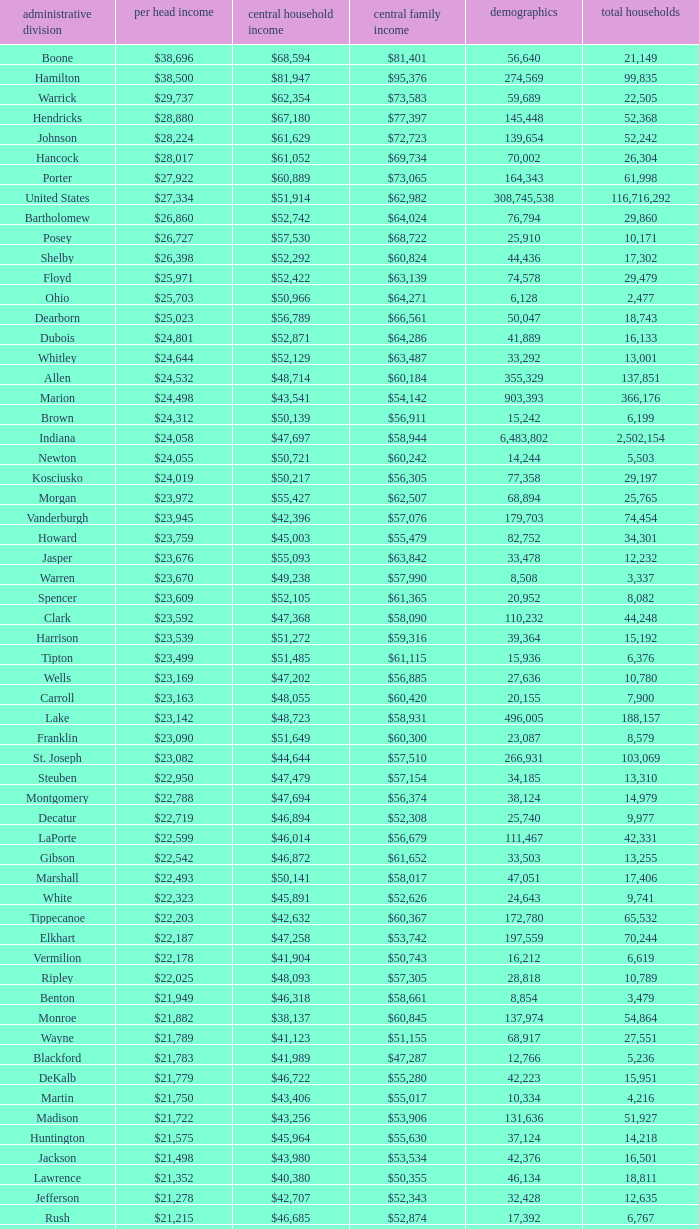What is the Median family income when the Median household income is $38,137? $60,845. Give me the full table as a dictionary. {'header': ['administrative division', 'per head income', 'central household income', 'central family income', 'demographics', 'total households'], 'rows': [['Boone', '$38,696', '$68,594', '$81,401', '56,640', '21,149'], ['Hamilton', '$38,500', '$81,947', '$95,376', '274,569', '99,835'], ['Warrick', '$29,737', '$62,354', '$73,583', '59,689', '22,505'], ['Hendricks', '$28,880', '$67,180', '$77,397', '145,448', '52,368'], ['Johnson', '$28,224', '$61,629', '$72,723', '139,654', '52,242'], ['Hancock', '$28,017', '$61,052', '$69,734', '70,002', '26,304'], ['Porter', '$27,922', '$60,889', '$73,065', '164,343', '61,998'], ['United States', '$27,334', '$51,914', '$62,982', '308,745,538', '116,716,292'], ['Bartholomew', '$26,860', '$52,742', '$64,024', '76,794', '29,860'], ['Posey', '$26,727', '$57,530', '$68,722', '25,910', '10,171'], ['Shelby', '$26,398', '$52,292', '$60,824', '44,436', '17,302'], ['Floyd', '$25,971', '$52,422', '$63,139', '74,578', '29,479'], ['Ohio', '$25,703', '$50,966', '$64,271', '6,128', '2,477'], ['Dearborn', '$25,023', '$56,789', '$66,561', '50,047', '18,743'], ['Dubois', '$24,801', '$52,871', '$64,286', '41,889', '16,133'], ['Whitley', '$24,644', '$52,129', '$63,487', '33,292', '13,001'], ['Allen', '$24,532', '$48,714', '$60,184', '355,329', '137,851'], ['Marion', '$24,498', '$43,541', '$54,142', '903,393', '366,176'], ['Brown', '$24,312', '$50,139', '$56,911', '15,242', '6,199'], ['Indiana', '$24,058', '$47,697', '$58,944', '6,483,802', '2,502,154'], ['Newton', '$24,055', '$50,721', '$60,242', '14,244', '5,503'], ['Kosciusko', '$24,019', '$50,217', '$56,305', '77,358', '29,197'], ['Morgan', '$23,972', '$55,427', '$62,507', '68,894', '25,765'], ['Vanderburgh', '$23,945', '$42,396', '$57,076', '179,703', '74,454'], ['Howard', '$23,759', '$45,003', '$55,479', '82,752', '34,301'], ['Jasper', '$23,676', '$55,093', '$63,842', '33,478', '12,232'], ['Warren', '$23,670', '$49,238', '$57,990', '8,508', '3,337'], ['Spencer', '$23,609', '$52,105', '$61,365', '20,952', '8,082'], ['Clark', '$23,592', '$47,368', '$58,090', '110,232', '44,248'], ['Harrison', '$23,539', '$51,272', '$59,316', '39,364', '15,192'], ['Tipton', '$23,499', '$51,485', '$61,115', '15,936', '6,376'], ['Wells', '$23,169', '$47,202', '$56,885', '27,636', '10,780'], ['Carroll', '$23,163', '$48,055', '$60,420', '20,155', '7,900'], ['Lake', '$23,142', '$48,723', '$58,931', '496,005', '188,157'], ['Franklin', '$23,090', '$51,649', '$60,300', '23,087', '8,579'], ['St. Joseph', '$23,082', '$44,644', '$57,510', '266,931', '103,069'], ['Steuben', '$22,950', '$47,479', '$57,154', '34,185', '13,310'], ['Montgomery', '$22,788', '$47,694', '$56,374', '38,124', '14,979'], ['Decatur', '$22,719', '$46,894', '$52,308', '25,740', '9,977'], ['LaPorte', '$22,599', '$46,014', '$56,679', '111,467', '42,331'], ['Gibson', '$22,542', '$46,872', '$61,652', '33,503', '13,255'], ['Marshall', '$22,493', '$50,141', '$58,017', '47,051', '17,406'], ['White', '$22,323', '$45,891', '$52,626', '24,643', '9,741'], ['Tippecanoe', '$22,203', '$42,632', '$60,367', '172,780', '65,532'], ['Elkhart', '$22,187', '$47,258', '$53,742', '197,559', '70,244'], ['Vermilion', '$22,178', '$41,904', '$50,743', '16,212', '6,619'], ['Ripley', '$22,025', '$48,093', '$57,305', '28,818', '10,789'], ['Benton', '$21,949', '$46,318', '$58,661', '8,854', '3,479'], ['Monroe', '$21,882', '$38,137', '$60,845', '137,974', '54,864'], ['Wayne', '$21,789', '$41,123', '$51,155', '68,917', '27,551'], ['Blackford', '$21,783', '$41,989', '$47,287', '12,766', '5,236'], ['DeKalb', '$21,779', '$46,722', '$55,280', '42,223', '15,951'], ['Martin', '$21,750', '$43,406', '$55,017', '10,334', '4,216'], ['Madison', '$21,722', '$43,256', '$53,906', '131,636', '51,927'], ['Huntington', '$21,575', '$45,964', '$55,630', '37,124', '14,218'], ['Jackson', '$21,498', '$43,980', '$53,534', '42,376', '16,501'], ['Lawrence', '$21,352', '$40,380', '$50,355', '46,134', '18,811'], ['Jefferson', '$21,278', '$42,707', '$52,343', '32,428', '12,635'], ['Rush', '$21,215', '$46,685', '$52,874', '17,392', '6,767'], ['Switzerland', '$21,214', '$44,503', '$51,769', '10,613', '4,034'], ['Clinton', '$21,131', '$48,416', '$57,445', '33,224', '12,105'], ['Fulton', '$21,119', '$40,372', '$47,972', '20,836', '8,237'], ['Fountain', '$20,949', '$42,817', '$51,696', '17,240', '6,935'], ['Perry', '$20,806', '$45,108', '$55,497', '19,338', '7,476'], ['Greene', '$20,676', '$41,103', '$50,740', '33,165', '13,487'], ['Owen', '$20,581', '$44,285', '$52,343', '21,575', '8,486'], ['Clay', '$20,569', '$44,666', '$52,907', '26,890', '10,447'], ['Cass', '$20,562', '$42,587', '$49,873', '38,966', '14,858'], ['Pulaski', '$20,491', '$44,016', '$50,903', '13,402', '5,282'], ['Wabash', '$20,475', '$43,157', '$52,758', '32,888', '12,777'], ['Putnam', '$20,441', '$48,992', '$59,354', '37,963', '12,917'], ['Delaware', '$20,405', '$38,066', '$51,394', '117,671', '46,516'], ['Vigo', '$20,398', '$38,508', '$50,413', '107,848', '41,361'], ['Knox', '$20,381', '$39,523', '$51,534', '38,440', '15,249'], ['Daviess', '$20,254', '$44,592', '$53,769', '31,648', '11,329'], ['Sullivan', '$20,093', '$44,184', '$52,558', '21,475', '7,823'], ['Pike', '$20,005', '$41,222', '$49,423', '12,845', '5,186'], ['Henry', '$19,879', '$41,087', '$52,701', '49,462', '19,077'], ['Grant', '$19,792', '$38,985', '$49,860', '70,061', '27,245'], ['Noble', '$19,783', '$45,818', '$53,959', '47,536', '17,355'], ['Randolph', '$19,552', '$40,990', '$45,543', '26,171', '10,451'], ['Parke', '$19,494', '$40,512', '$51,581', '17,339', '6,222'], ['Scott', '$19,414', '$39,588', '$46,775', '24,181', '9,397'], ['Washington', '$19,278', '$39,722', '$45,500', '28,262', '10,850'], ['Union', '$19,243', '$43,257', '$49,815', '7,516', '2,938'], ['Orange', '$19,119', '$37,120', '$45,874', '19,840', '7,872'], ['Adams', '$19,089', '$43,317', '$53,106', '34,387', '12,011'], ['Jay', '$18,946', '$39,886', '$47,926', '21,253', '8,133'], ['Fayette', '$18,928', '$37,038', '$46,601', '24,277', '9,719'], ['Miami', '$18,854', '$39,485', '$49,282', '36,903', '13,456'], ['Jennings', '$18,636', '$43,755', '$48,470', '28,525', '10,680'], ['Crawford', '$18,598', '$37,988', '$46,073', '10,713', '4,303'], ['LaGrange', '$18,388', '$47,792', '$53,793', '37,128', '11,598'], ['Starke', '$17,991', '$37,480', '$44,044', '23,363', '9,038']]} 